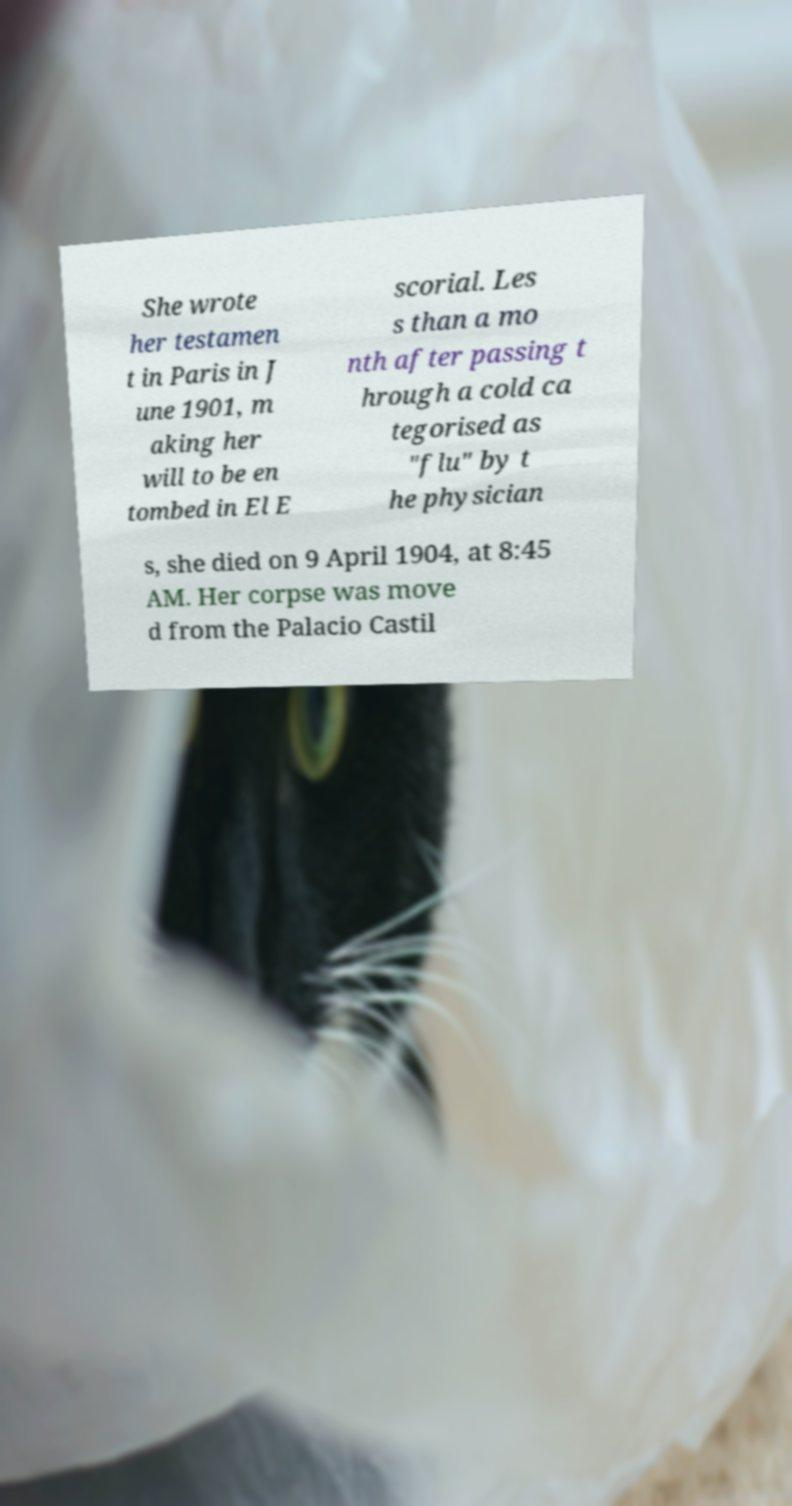Please identify and transcribe the text found in this image. She wrote her testamen t in Paris in J une 1901, m aking her will to be en tombed in El E scorial. Les s than a mo nth after passing t hrough a cold ca tegorised as "flu" by t he physician s, she died on 9 April 1904, at 8:45 AM. Her corpse was move d from the Palacio Castil 